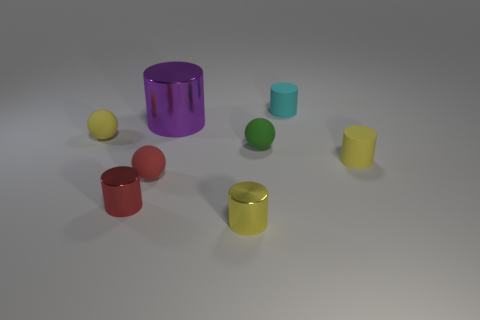What material is the small thing behind the tiny yellow thing to the left of the tiny red sphere left of the yellow metallic object?
Your answer should be very brief. Rubber. Are there the same number of large purple metal cylinders that are in front of the red rubber object and red spheres?
Provide a succinct answer. No. Are there any other things that have the same size as the purple cylinder?
Provide a short and direct response. No. What number of things are purple metallic objects or big brown rubber balls?
Offer a very short reply. 1. What is the shape of the red thing that is the same material as the green sphere?
Your response must be concise. Sphere. What is the size of the matte cylinder to the left of the cylinder on the right side of the tiny cyan rubber thing?
Your answer should be very brief. Small. What number of small objects are either purple cylinders or yellow spheres?
Give a very brief answer. 1. How many other things are the same color as the big metal cylinder?
Provide a short and direct response. 0. Does the yellow cylinder that is behind the tiny yellow metallic object have the same size as the yellow cylinder left of the small cyan rubber cylinder?
Provide a succinct answer. Yes. Do the cyan thing and the tiny sphere that is in front of the tiny green thing have the same material?
Offer a terse response. Yes. 